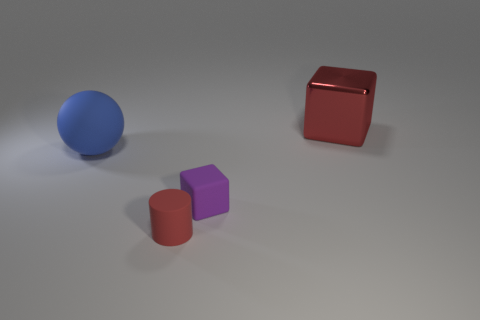Add 2 brown objects. How many objects exist? 6 Subtract all cylinders. How many objects are left? 3 Add 4 big green matte blocks. How many big green matte blocks exist? 4 Subtract 0 brown cubes. How many objects are left? 4 Subtract all big yellow spheres. Subtract all small purple cubes. How many objects are left? 3 Add 3 purple cubes. How many purple cubes are left? 4 